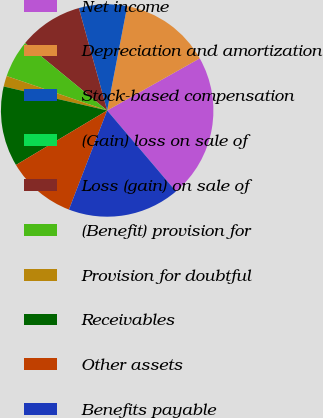<chart> <loc_0><loc_0><loc_500><loc_500><pie_chart><fcel>Net income<fcel>Depreciation and amortization<fcel>Stock-based compensation<fcel>(Gain) loss on sale of<fcel>Loss (gain) on sale of<fcel>(Benefit) provision for<fcel>Provision for doubtful<fcel>Receivables<fcel>Other assets<fcel>Benefits payable<nl><fcel>21.95%<fcel>13.82%<fcel>7.32%<fcel>0.0%<fcel>9.76%<fcel>5.69%<fcel>1.63%<fcel>12.2%<fcel>10.57%<fcel>17.07%<nl></chart> 